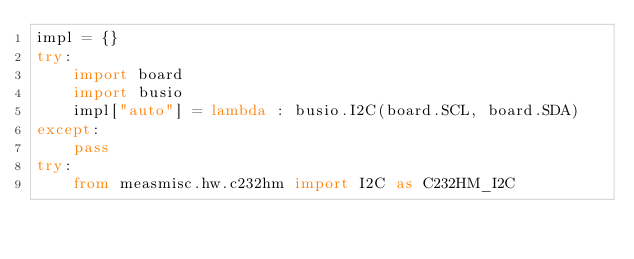<code> <loc_0><loc_0><loc_500><loc_500><_Python_>impl = {}
try:
	import board
	import busio
	impl["auto"] = lambda : busio.I2C(board.SCL, board.SDA)
except:
	pass
try:
	from measmisc.hw.c232hm import I2C as C232HM_I2C</code> 